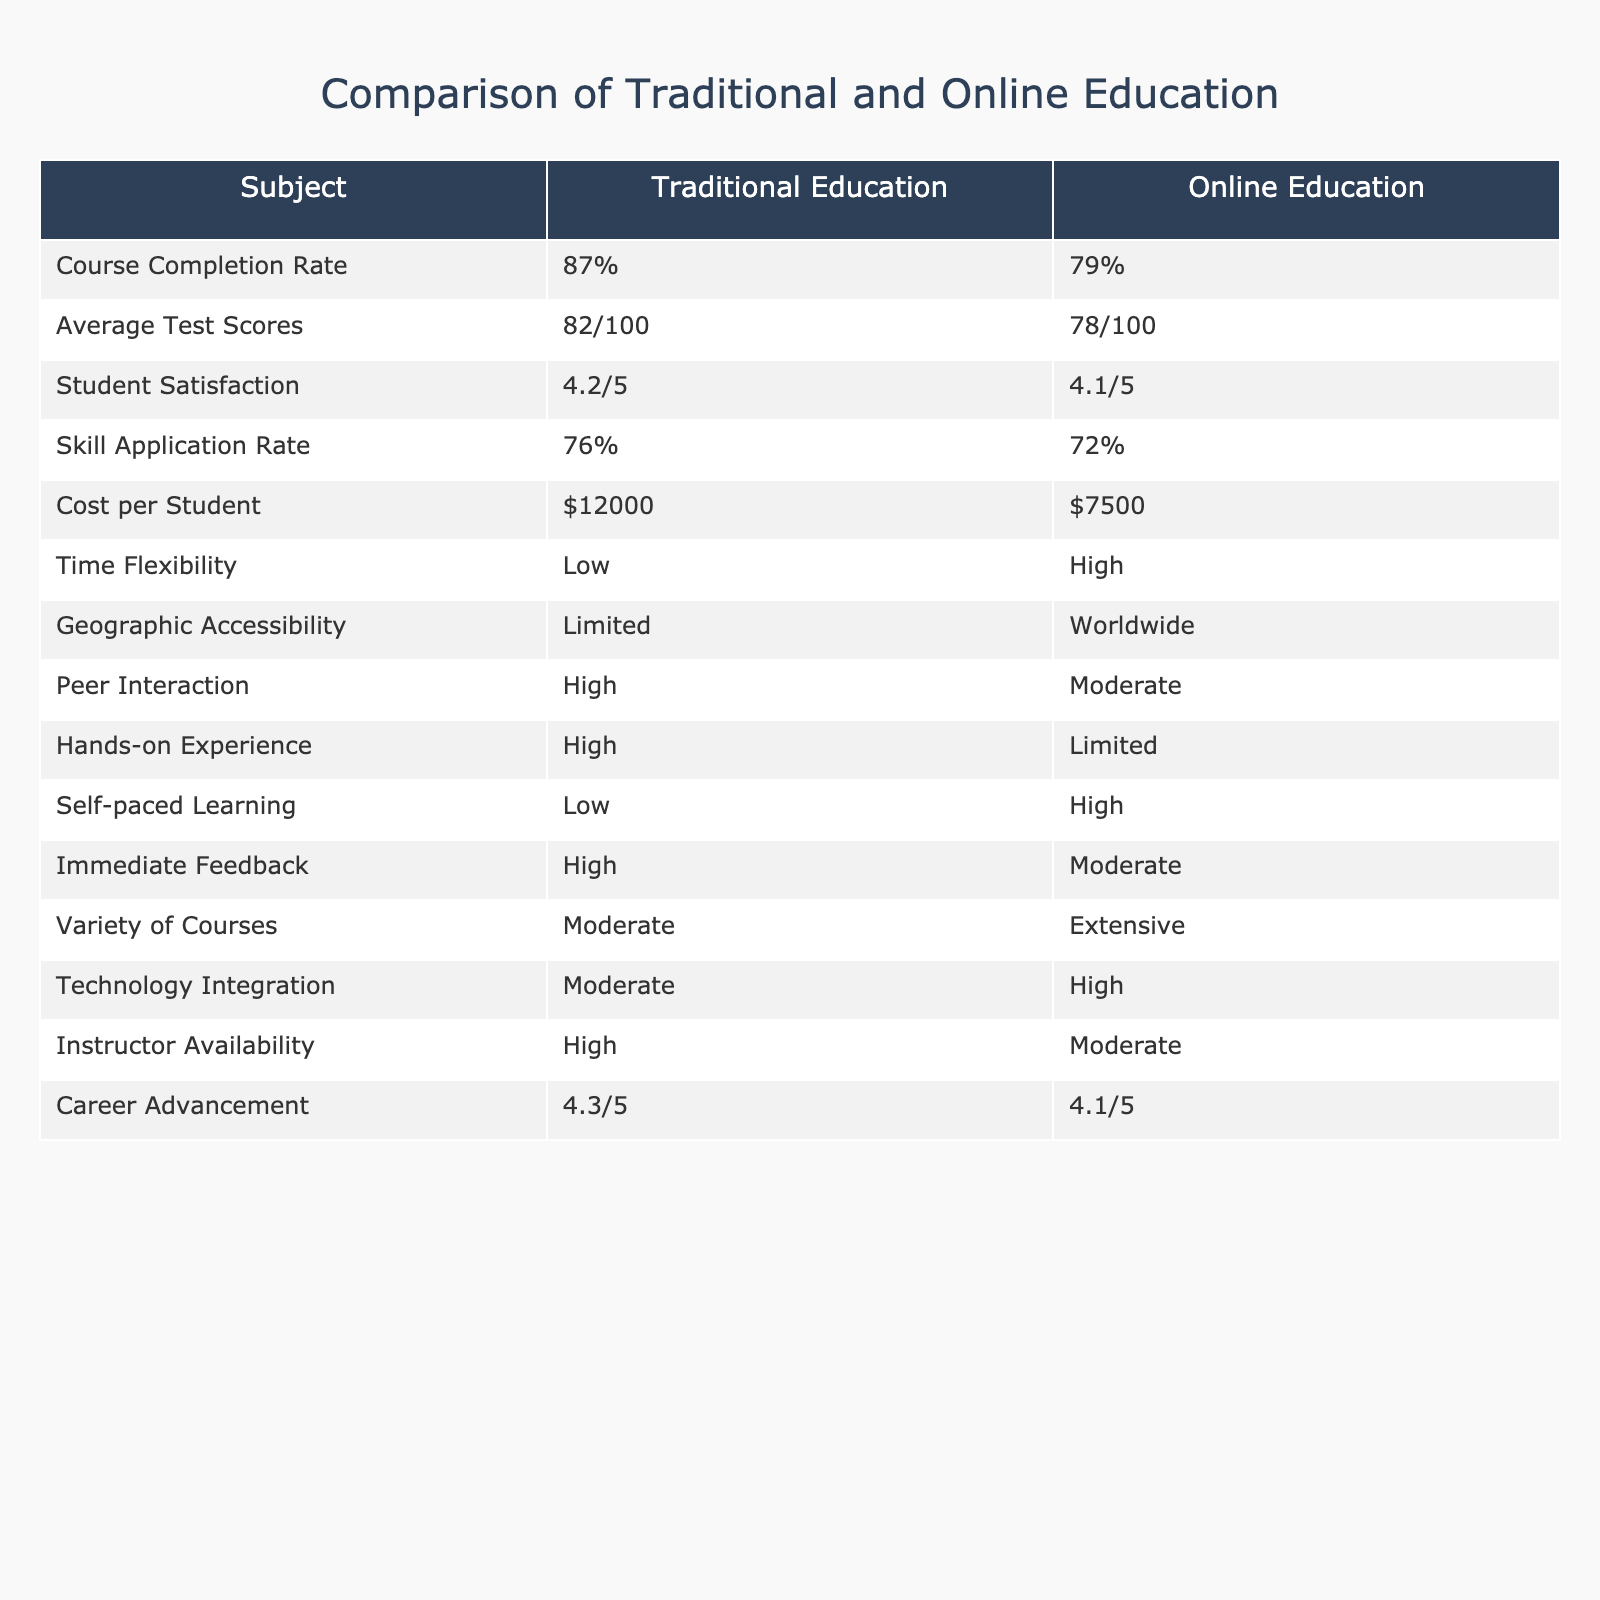What is the course completion rate for traditional education? The table lists the course completion rate under the "Course Completion Rate" row for traditional education, which is specified as 87%.
Answer: 87% What is the average test score for online education? The average test score for online education is found in the "Average Test Scores" row under the online education column, which shows 78/100.
Answer: 78/100 Which education method has a higher student satisfaction score? By comparing the "Student Satisfaction" scores of both methods, traditional education has a score of 4.2/5 while online education has a score of 4.1/5, indicating traditional education is higher.
Answer: Traditional education Is the skill application rate higher for online education compared to traditional education? The skill application rate for traditional education is 76%, while for online education it is 72%. Since 76% is greater than 72%, the statement is false.
Answer: No What is the difference in cost per student between traditional and online education? The cost per student for traditional education is $12000 and for online education is $7500. Calculating the difference, $12000 - $7500 = $4500.
Answer: $4500 In terms of geographic accessibility, which education type is more accessible? The table indicates that traditional education has "Limited" geographic accessibility, while online education has "Worldwide" accessibility. Therefore, online education is more accessible.
Answer: Online education What is the average rating for career advancement in traditional education? The career advancement rating for traditional education is 4.3/5, as shown in the "Career Advancement" row under traditional education.
Answer: 4.3/5 Is there a difference in peer interaction between traditional and online education? Traditional education has "High" peer interaction, while online education has "Moderate" peer interaction. Since "High" is greater than "Moderate", there is a difference.
Answer: Yes Which education method provides more time flexibility? By looking at the "Time Flexibility" row, traditional education states "Low", whereas online education states "High". This indicates that online education provides more flexibility.
Answer: Online education Does traditional education offer more hands-on experience than online education? Referring to the "Hands-on Experience" row, traditional education is categorized as "High", while online education is categorized as "Limited". Thus, traditional education offers more hands-on experience.
Answer: Yes 